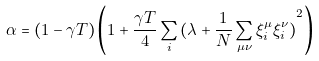<formula> <loc_0><loc_0><loc_500><loc_500>\alpha = ( 1 - \gamma T ) \left ( 1 + \frac { \gamma T } { 4 } \sum _ { i } { ( \lambda + \frac { 1 } { N } \sum _ { \mu \nu } \xi ^ { \mu } _ { i } \xi ^ { \nu } _ { i } ) } ^ { 2 } \right )</formula> 